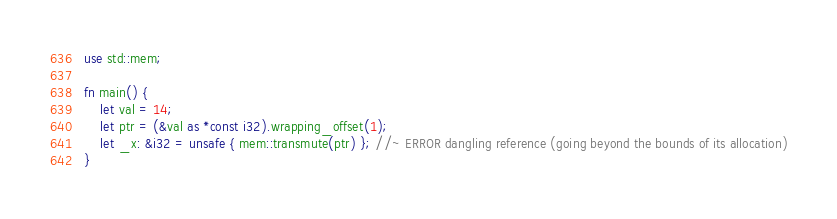<code> <loc_0><loc_0><loc_500><loc_500><_Rust_>use std::mem;

fn main() {
    let val = 14;
    let ptr = (&val as *const i32).wrapping_offset(1);
    let _x: &i32 = unsafe { mem::transmute(ptr) }; //~ ERROR dangling reference (going beyond the bounds of its allocation)
}
</code> 